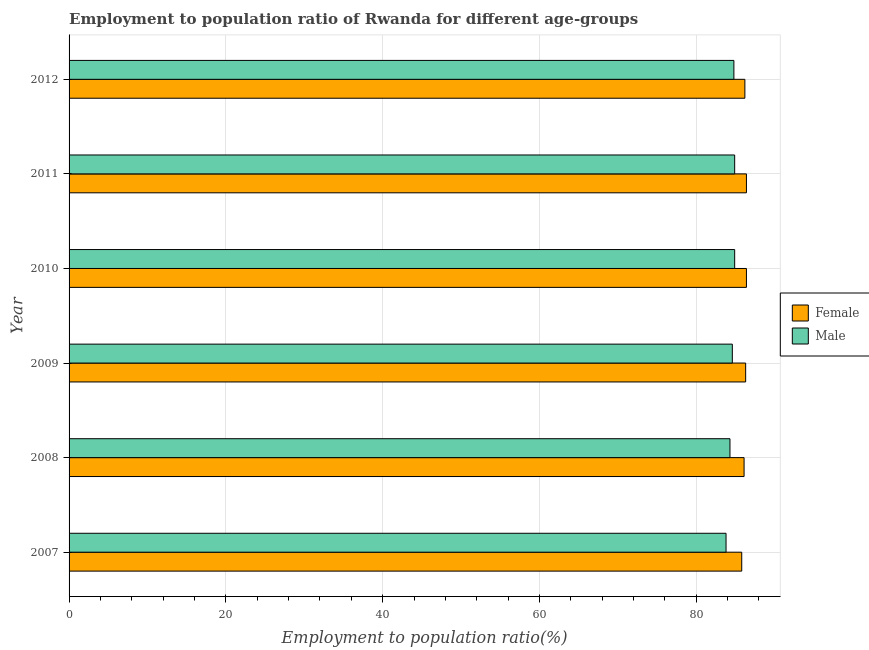How many different coloured bars are there?
Offer a terse response. 2. Are the number of bars per tick equal to the number of legend labels?
Give a very brief answer. Yes. Are the number of bars on each tick of the Y-axis equal?
Provide a succinct answer. Yes. How many bars are there on the 6th tick from the top?
Your answer should be compact. 2. What is the label of the 3rd group of bars from the top?
Keep it short and to the point. 2010. In how many cases, is the number of bars for a given year not equal to the number of legend labels?
Keep it short and to the point. 0. What is the employment to population ratio(female) in 2011?
Make the answer very short. 86.4. Across all years, what is the maximum employment to population ratio(male)?
Make the answer very short. 84.9. Across all years, what is the minimum employment to population ratio(female)?
Offer a very short reply. 85.8. What is the total employment to population ratio(male) in the graph?
Your response must be concise. 507.3. What is the difference between the employment to population ratio(male) in 2007 and that in 2012?
Provide a short and direct response. -1. What is the difference between the employment to population ratio(female) in 2009 and the employment to population ratio(male) in 2007?
Your answer should be compact. 2.5. What is the average employment to population ratio(female) per year?
Offer a very short reply. 86.2. In the year 2010, what is the difference between the employment to population ratio(female) and employment to population ratio(male)?
Provide a succinct answer. 1.5. In how many years, is the employment to population ratio(male) greater than 48 %?
Offer a terse response. 6. What is the ratio of the employment to population ratio(male) in 2007 to that in 2008?
Your answer should be compact. 0.99. Is the employment to population ratio(male) in 2007 less than that in 2009?
Provide a short and direct response. Yes. Is the difference between the employment to population ratio(female) in 2007 and 2010 greater than the difference between the employment to population ratio(male) in 2007 and 2010?
Offer a terse response. Yes. In how many years, is the employment to population ratio(female) greater than the average employment to population ratio(female) taken over all years?
Provide a succinct answer. 3. Is the sum of the employment to population ratio(female) in 2007 and 2011 greater than the maximum employment to population ratio(male) across all years?
Offer a terse response. Yes. How many bars are there?
Make the answer very short. 12. Are all the bars in the graph horizontal?
Offer a very short reply. Yes. Are the values on the major ticks of X-axis written in scientific E-notation?
Your answer should be very brief. No. What is the title of the graph?
Your answer should be compact. Employment to population ratio of Rwanda for different age-groups. Does "Female entrants" appear as one of the legend labels in the graph?
Provide a short and direct response. No. What is the label or title of the X-axis?
Provide a succinct answer. Employment to population ratio(%). What is the Employment to population ratio(%) in Female in 2007?
Provide a succinct answer. 85.8. What is the Employment to population ratio(%) in Male in 2007?
Provide a short and direct response. 83.8. What is the Employment to population ratio(%) of Female in 2008?
Keep it short and to the point. 86.1. What is the Employment to population ratio(%) in Male in 2008?
Your response must be concise. 84.3. What is the Employment to population ratio(%) in Female in 2009?
Your response must be concise. 86.3. What is the Employment to population ratio(%) in Male in 2009?
Your answer should be compact. 84.6. What is the Employment to population ratio(%) of Female in 2010?
Ensure brevity in your answer.  86.4. What is the Employment to population ratio(%) of Male in 2010?
Provide a short and direct response. 84.9. What is the Employment to population ratio(%) of Female in 2011?
Ensure brevity in your answer.  86.4. What is the Employment to population ratio(%) in Male in 2011?
Provide a short and direct response. 84.9. What is the Employment to population ratio(%) of Female in 2012?
Your response must be concise. 86.2. What is the Employment to population ratio(%) in Male in 2012?
Provide a short and direct response. 84.8. Across all years, what is the maximum Employment to population ratio(%) in Female?
Provide a succinct answer. 86.4. Across all years, what is the maximum Employment to population ratio(%) of Male?
Keep it short and to the point. 84.9. Across all years, what is the minimum Employment to population ratio(%) of Female?
Your answer should be compact. 85.8. Across all years, what is the minimum Employment to population ratio(%) in Male?
Give a very brief answer. 83.8. What is the total Employment to population ratio(%) in Female in the graph?
Offer a terse response. 517.2. What is the total Employment to population ratio(%) of Male in the graph?
Offer a very short reply. 507.3. What is the difference between the Employment to population ratio(%) of Male in 2007 and that in 2008?
Your answer should be compact. -0.5. What is the difference between the Employment to population ratio(%) of Female in 2007 and that in 2010?
Your answer should be very brief. -0.6. What is the difference between the Employment to population ratio(%) of Male in 2007 and that in 2010?
Ensure brevity in your answer.  -1.1. What is the difference between the Employment to population ratio(%) in Female in 2007 and that in 2011?
Offer a very short reply. -0.6. What is the difference between the Employment to population ratio(%) in Male in 2007 and that in 2011?
Make the answer very short. -1.1. What is the difference between the Employment to population ratio(%) of Female in 2007 and that in 2012?
Your answer should be very brief. -0.4. What is the difference between the Employment to population ratio(%) in Female in 2008 and that in 2009?
Offer a terse response. -0.2. What is the difference between the Employment to population ratio(%) in Female in 2008 and that in 2010?
Your answer should be compact. -0.3. What is the difference between the Employment to population ratio(%) of Female in 2008 and that in 2011?
Make the answer very short. -0.3. What is the difference between the Employment to population ratio(%) of Female in 2008 and that in 2012?
Provide a short and direct response. -0.1. What is the difference between the Employment to population ratio(%) of Male in 2008 and that in 2012?
Your response must be concise. -0.5. What is the difference between the Employment to population ratio(%) in Female in 2009 and that in 2010?
Give a very brief answer. -0.1. What is the difference between the Employment to population ratio(%) of Female in 2009 and that in 2011?
Offer a terse response. -0.1. What is the difference between the Employment to population ratio(%) in Male in 2009 and that in 2011?
Ensure brevity in your answer.  -0.3. What is the difference between the Employment to population ratio(%) of Female in 2009 and that in 2012?
Make the answer very short. 0.1. What is the difference between the Employment to population ratio(%) of Male in 2009 and that in 2012?
Your answer should be compact. -0.2. What is the difference between the Employment to population ratio(%) of Female in 2010 and that in 2012?
Your answer should be very brief. 0.2. What is the difference between the Employment to population ratio(%) of Male in 2010 and that in 2012?
Keep it short and to the point. 0.1. What is the difference between the Employment to population ratio(%) in Female in 2011 and that in 2012?
Ensure brevity in your answer.  0.2. What is the difference between the Employment to population ratio(%) of Female in 2007 and the Employment to population ratio(%) of Male in 2008?
Offer a very short reply. 1.5. What is the difference between the Employment to population ratio(%) in Female in 2007 and the Employment to population ratio(%) in Male in 2009?
Your answer should be very brief. 1.2. What is the difference between the Employment to population ratio(%) of Female in 2007 and the Employment to population ratio(%) of Male in 2010?
Provide a short and direct response. 0.9. What is the difference between the Employment to population ratio(%) in Female in 2008 and the Employment to population ratio(%) in Male in 2009?
Provide a succinct answer. 1.5. What is the difference between the Employment to population ratio(%) of Female in 2008 and the Employment to population ratio(%) of Male in 2010?
Give a very brief answer. 1.2. What is the difference between the Employment to population ratio(%) of Female in 2008 and the Employment to population ratio(%) of Male in 2012?
Your response must be concise. 1.3. What is the difference between the Employment to population ratio(%) of Female in 2009 and the Employment to population ratio(%) of Male in 2010?
Your response must be concise. 1.4. What is the difference between the Employment to population ratio(%) of Female in 2011 and the Employment to population ratio(%) of Male in 2012?
Make the answer very short. 1.6. What is the average Employment to population ratio(%) in Female per year?
Offer a very short reply. 86.2. What is the average Employment to population ratio(%) in Male per year?
Your answer should be compact. 84.55. What is the ratio of the Employment to population ratio(%) in Female in 2007 to that in 2008?
Your answer should be very brief. 1. What is the ratio of the Employment to population ratio(%) in Male in 2007 to that in 2009?
Provide a succinct answer. 0.99. What is the ratio of the Employment to population ratio(%) of Male in 2007 to that in 2010?
Provide a succinct answer. 0.99. What is the ratio of the Employment to population ratio(%) of Male in 2007 to that in 2012?
Offer a terse response. 0.99. What is the ratio of the Employment to population ratio(%) in Female in 2008 to that in 2009?
Your answer should be compact. 1. What is the ratio of the Employment to population ratio(%) of Male in 2008 to that in 2009?
Offer a very short reply. 1. What is the ratio of the Employment to population ratio(%) in Female in 2008 to that in 2010?
Keep it short and to the point. 1. What is the ratio of the Employment to population ratio(%) of Male in 2008 to that in 2011?
Provide a short and direct response. 0.99. What is the ratio of the Employment to population ratio(%) in Female in 2008 to that in 2012?
Your response must be concise. 1. What is the ratio of the Employment to population ratio(%) in Male in 2008 to that in 2012?
Your answer should be compact. 0.99. What is the ratio of the Employment to population ratio(%) of Female in 2009 to that in 2011?
Your answer should be compact. 1. What is the ratio of the Employment to population ratio(%) of Female in 2009 to that in 2012?
Offer a terse response. 1. What is the ratio of the Employment to population ratio(%) in Male in 2009 to that in 2012?
Provide a succinct answer. 1. What is the ratio of the Employment to population ratio(%) in Female in 2010 to that in 2011?
Offer a very short reply. 1. What is the ratio of the Employment to population ratio(%) in Female in 2010 to that in 2012?
Your answer should be very brief. 1. What is the ratio of the Employment to population ratio(%) in Female in 2011 to that in 2012?
Ensure brevity in your answer.  1. What is the ratio of the Employment to population ratio(%) of Male in 2011 to that in 2012?
Provide a succinct answer. 1. What is the difference between the highest and the second highest Employment to population ratio(%) in Female?
Ensure brevity in your answer.  0. 